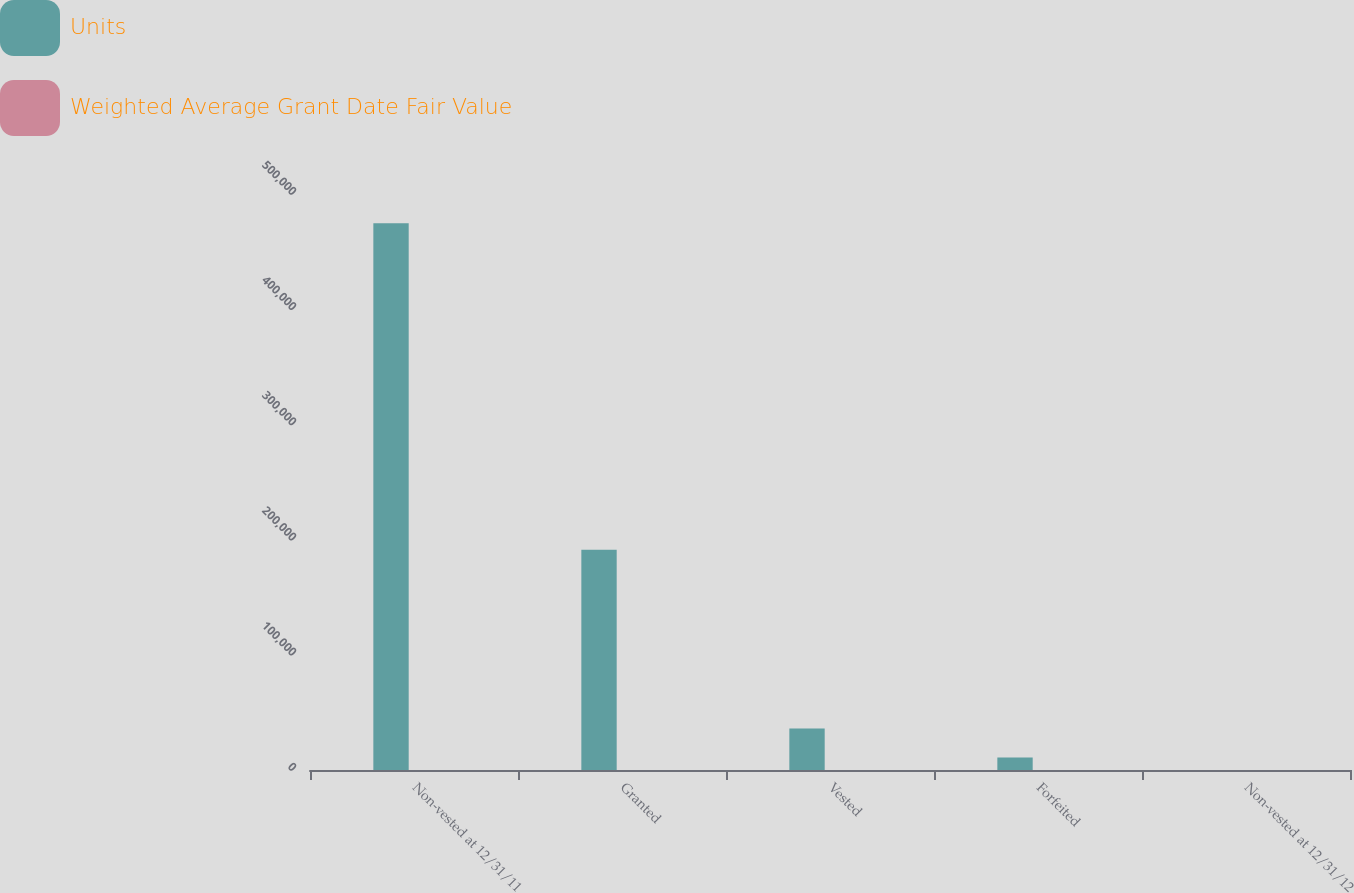Convert chart to OTSL. <chart><loc_0><loc_0><loc_500><loc_500><stacked_bar_chart><ecel><fcel>Non-vested at 12/31/11<fcel>Granted<fcel>Vested<fcel>Forfeited<fcel>Non-vested at 12/31/12<nl><fcel>Units<fcel>474517<fcel>191280<fcel>36075<fcel>10812<fcel>49.51<nl><fcel>Weighted Average Grant Date Fair Value<fcel>42.51<fcel>49.51<fcel>41.87<fcel>45.45<fcel>44.66<nl></chart> 